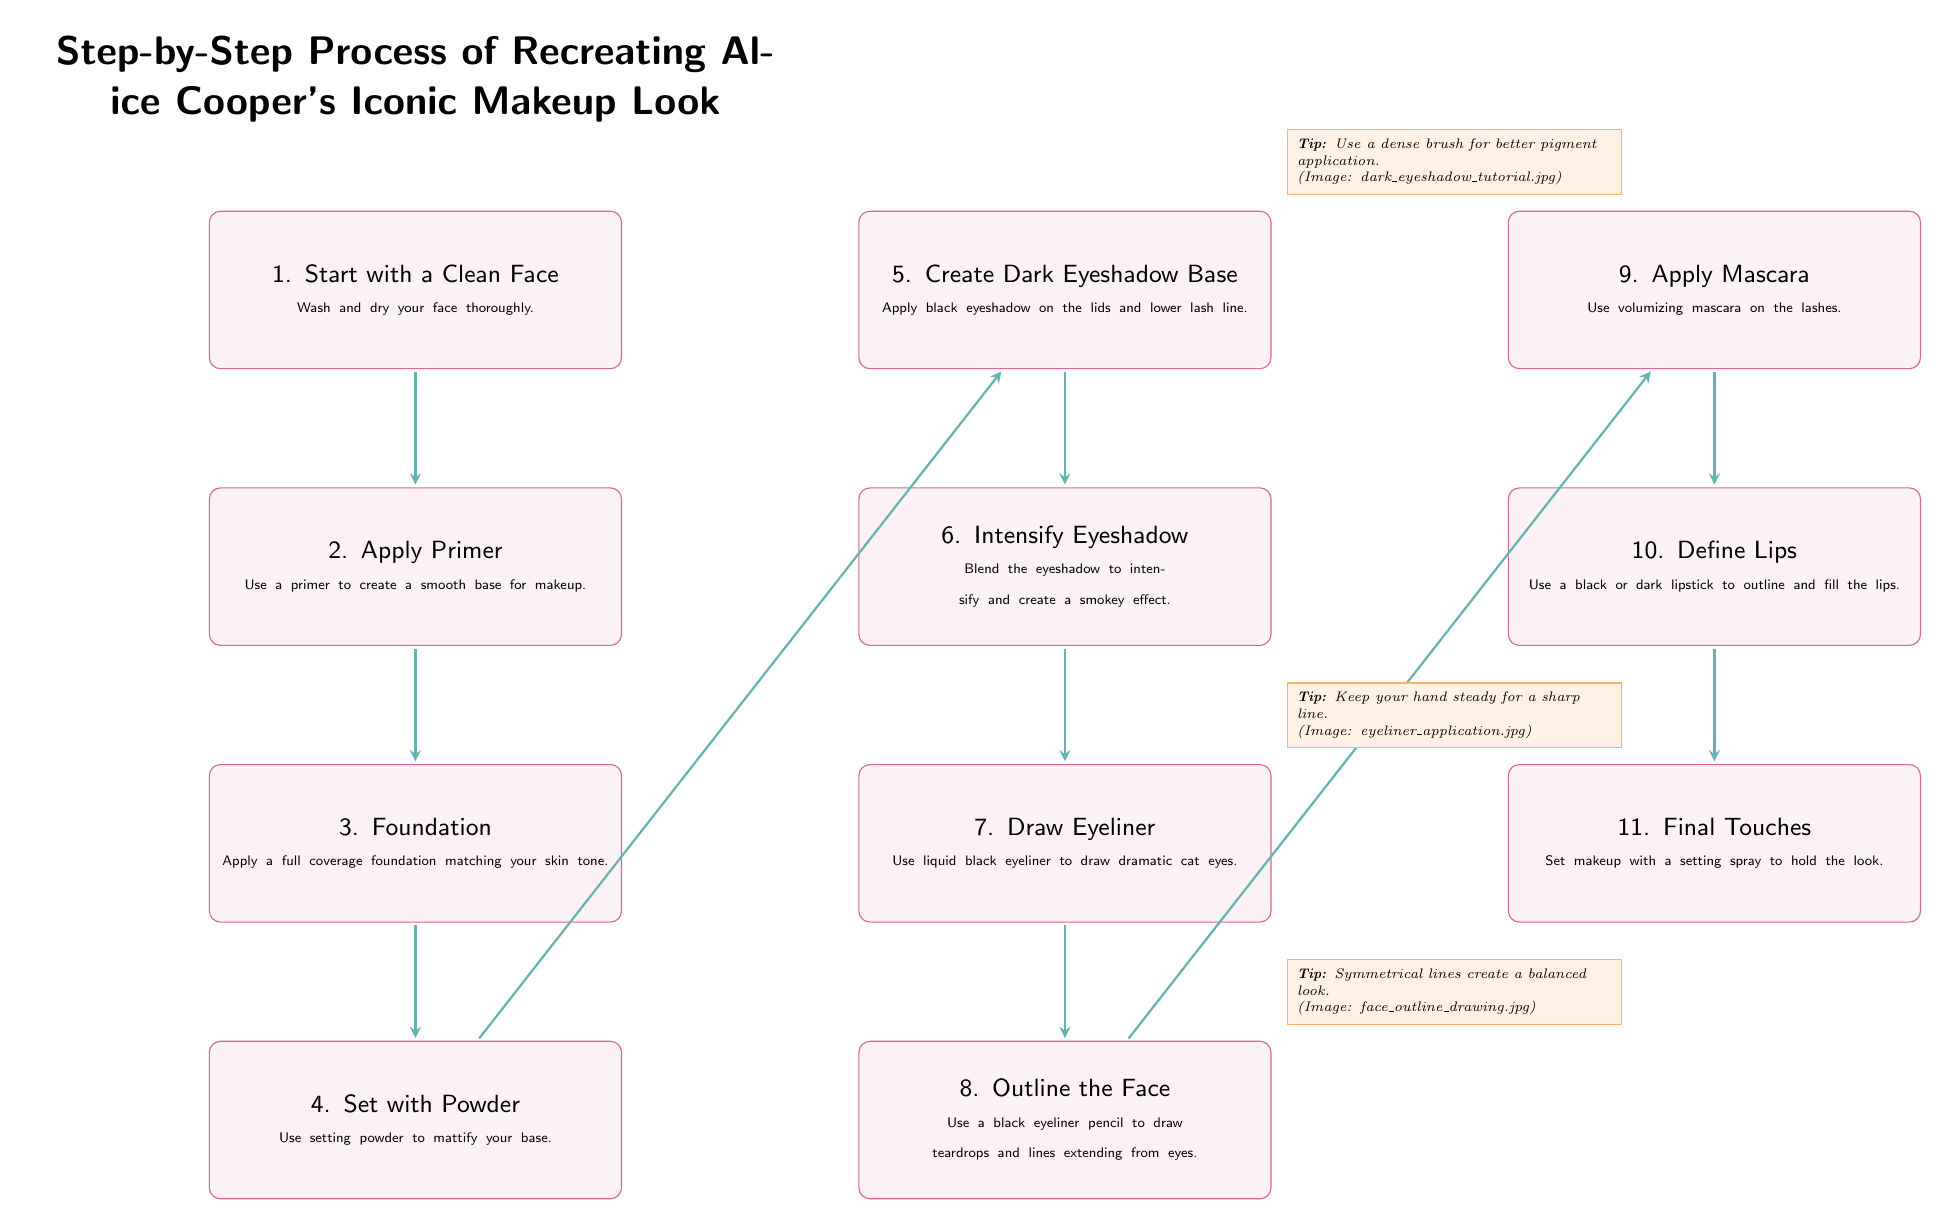What is the first step in the makeup process? The first step in the process is stated clearly in the diagram as "Start with a Clean Face." This is the initial box at the top of the flow, indicating that it is the first action to take.
Answer: Start with a Clean Face How many total steps are there in the diagram? By counting the number of boxes in the diagram, including all steps from the beginning to the final touch, there are eleven distinct steps outlined.
Answer: 11 Which step follows the application of foundation? The diagram shows a direct flow where the step following "Foundation" is "Set with Powder." This is confirmed by tracing the arrow connecting these two steps.
Answer: Set with Powder What type of eyeliner is used according to the makeup steps? The diagram specifies the type of eyeliner to use in step 7, which is "liquid black eyeliner." This detail helps to clarify the specific product recommended in the process.
Answer: liquid black eyeliner What is recommended for better pigment application in dark eyeshadow? In the annotation next to step 5, it is indicated that using a "dense brush" is recommended for applying dark eyeshadow. This tip provides a specific technique to enhance application.
Answer: dense brush What should be the focus while drawing eyeliner? According to the annotation next to step 7, it’s advised to "keep your hand steady" when drawing eyeliner. This emphasizes the need for control during application to achieve the desired look.
Answer: keep your hand steady Which step involves defining the lips? The diagram clearly indicates that the step for outlining and filling the lips is step 10, labelled as "Define Lips." This specifies which step is dedicated to lip makeup.
Answer: Define Lips What is the final step in the process? The bottom box of the flow diagram lists the last step as "Final Touches," indicating that this is the concluding part of the makeup application sequence.
Answer: Final Touches How does the eyeshadow application flow connect to eyeliner? Based on the diagram, the application of eyeshadow (steps 5 and 6) directly connects to the drawing of eyeliner (step 7) through a sequential arrow, indicating that these steps are related in the makeup process.
Answer: directly connected through arrows 